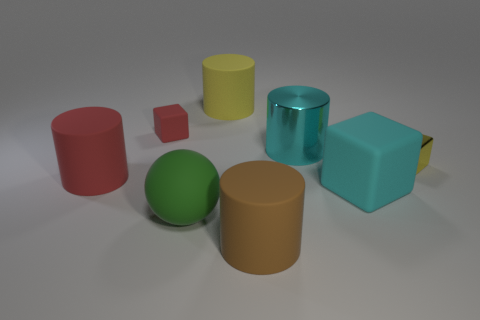There is a shiny thing that is the same shape as the big yellow rubber thing; what is its color?
Provide a short and direct response. Cyan. There is a block in front of the big red rubber thing; does it have the same color as the small rubber block?
Give a very brief answer. No. Is the shiny block the same size as the yellow rubber thing?
Ensure brevity in your answer.  No. What is the shape of the large green object that is made of the same material as the big yellow cylinder?
Make the answer very short. Sphere. What number of other objects are the same shape as the big red thing?
Offer a very short reply. 3. The tiny object that is to the right of the large cylinder that is behind the red object on the right side of the red matte cylinder is what shape?
Give a very brief answer. Cube. What number of cylinders are big green objects or tiny matte things?
Make the answer very short. 0. There is a large matte thing on the left side of the big green sphere; are there any things right of it?
Provide a succinct answer. Yes. Does the tiny yellow object have the same shape as the red thing right of the big red object?
Your answer should be compact. Yes. How many other objects are the same size as the brown rubber object?
Your response must be concise. 5. 